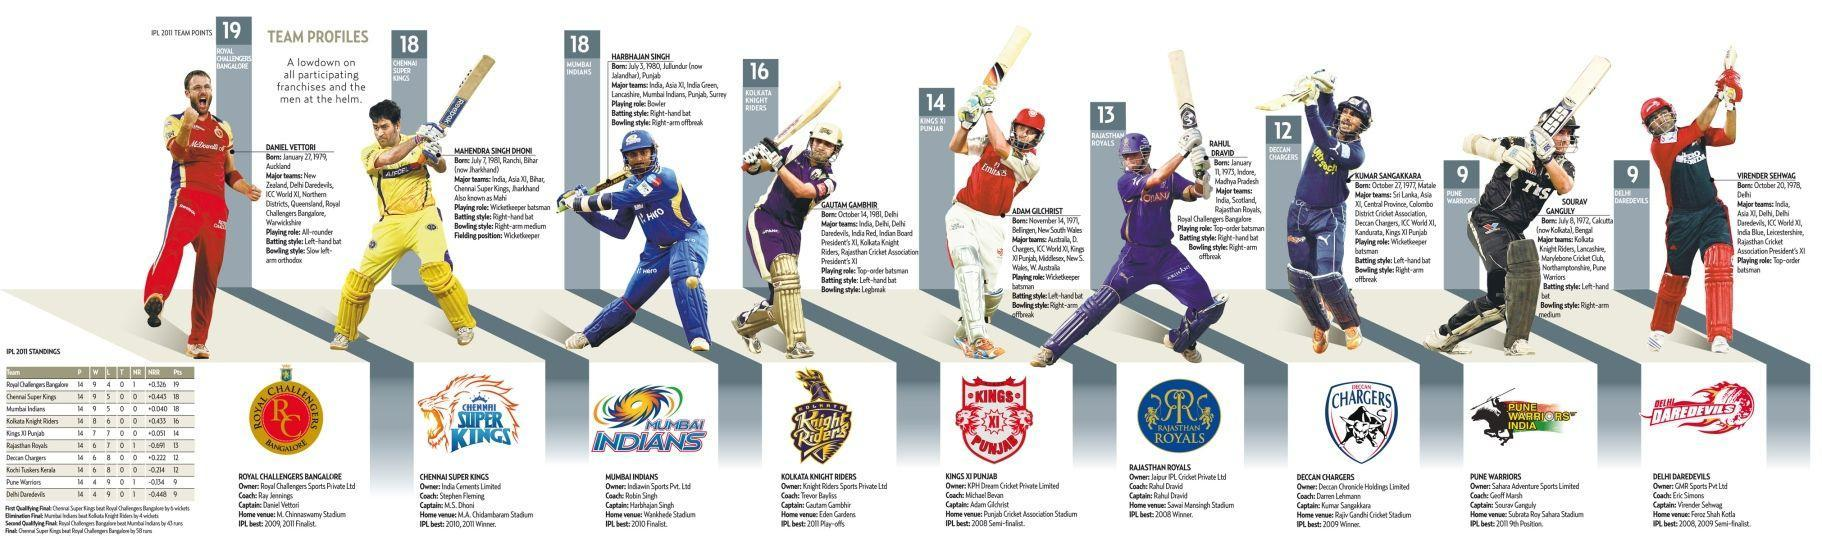Which team won second place in IPL 2011?
Answer the question with a short phrase. Chennai Super kings What is the Batting style of Sourav Ganguly? Left-hand bat Where is the Home Ground of Kolkata Knight Riders? Eden Gardens Who is the coach of Kings XI Punjab? Michael Bevan What is the Playing-role of Daniel Vettori? All-rounder Who is the captain of Deccan Chargers? Kumar Sangakkara Who is the captain of Pune Warriors? Sourav Ganguly Who is the owner of the team Chennai Super Kings? India Cements Limited When is the birthday of Mahi? July 7, 1981 What is the win percentage of Royal Challengers Bangalore? 64.2857 